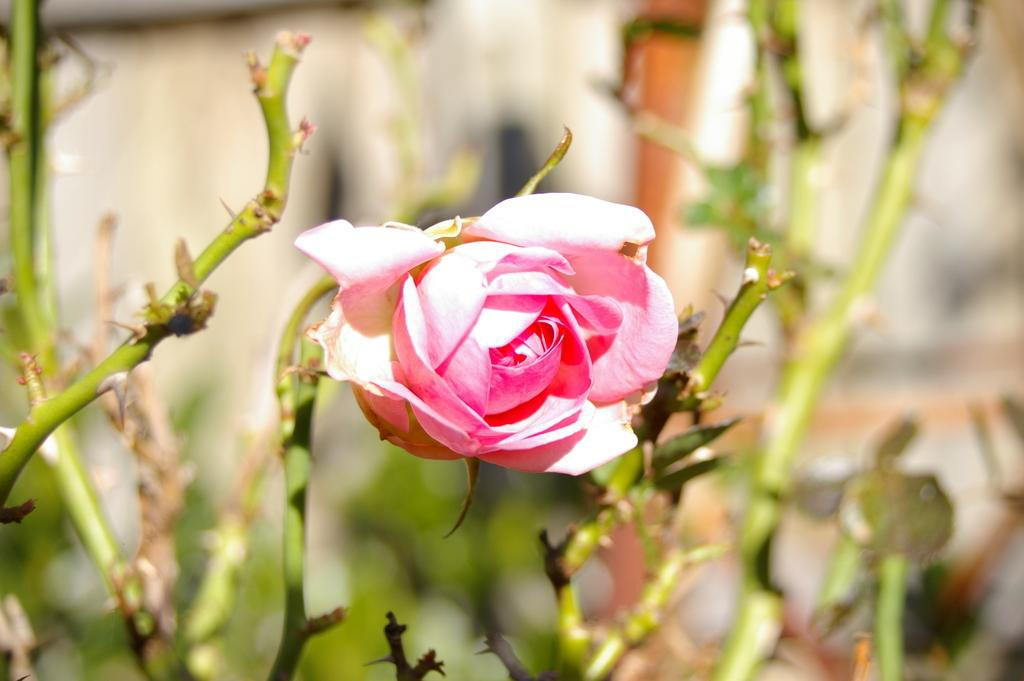What is the main subject of the image? There is a plant in the image. What type of flower is on the plant? The plant has a pink rose flower. Can you describe any other objects visible in the image? There are other objects in the background of the image. What credit score does the plant have in the image? There is no credit score associated with the plant in the image, as plants do not have credit scores. 